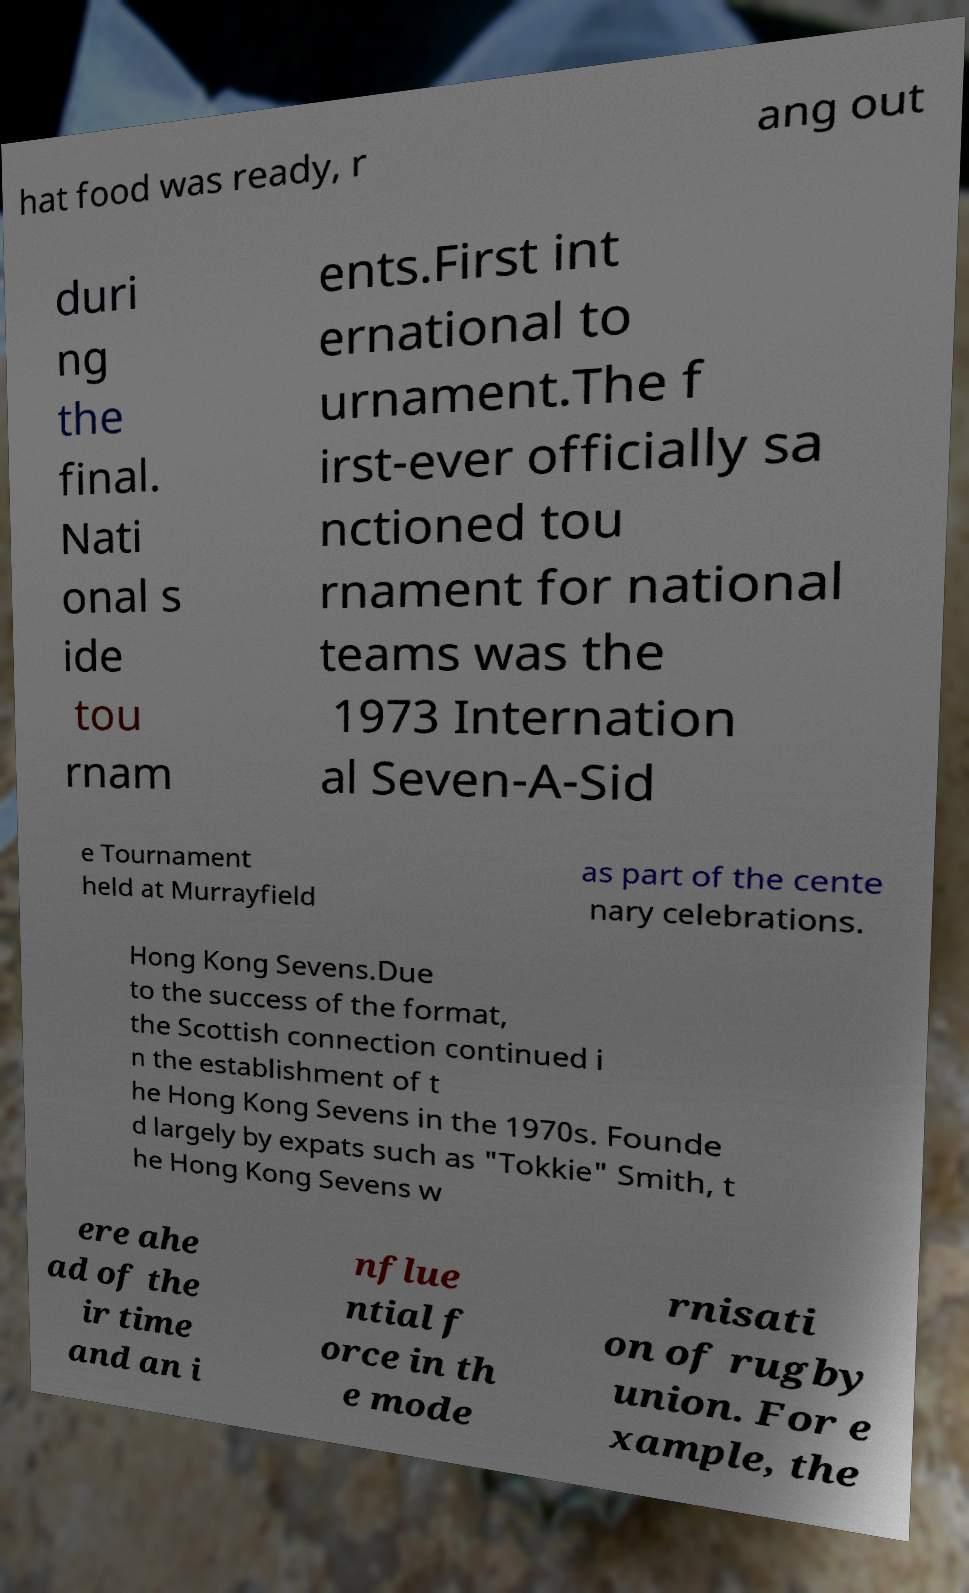I need the written content from this picture converted into text. Can you do that? hat food was ready, r ang out duri ng the final. Nati onal s ide tou rnam ents.First int ernational to urnament.The f irst-ever officially sa nctioned tou rnament for national teams was the 1973 Internation al Seven-A-Sid e Tournament held at Murrayfield as part of the cente nary celebrations. Hong Kong Sevens.Due to the success of the format, the Scottish connection continued i n the establishment of t he Hong Kong Sevens in the 1970s. Founde d largely by expats such as "Tokkie" Smith, t he Hong Kong Sevens w ere ahe ad of the ir time and an i nflue ntial f orce in th e mode rnisati on of rugby union. For e xample, the 